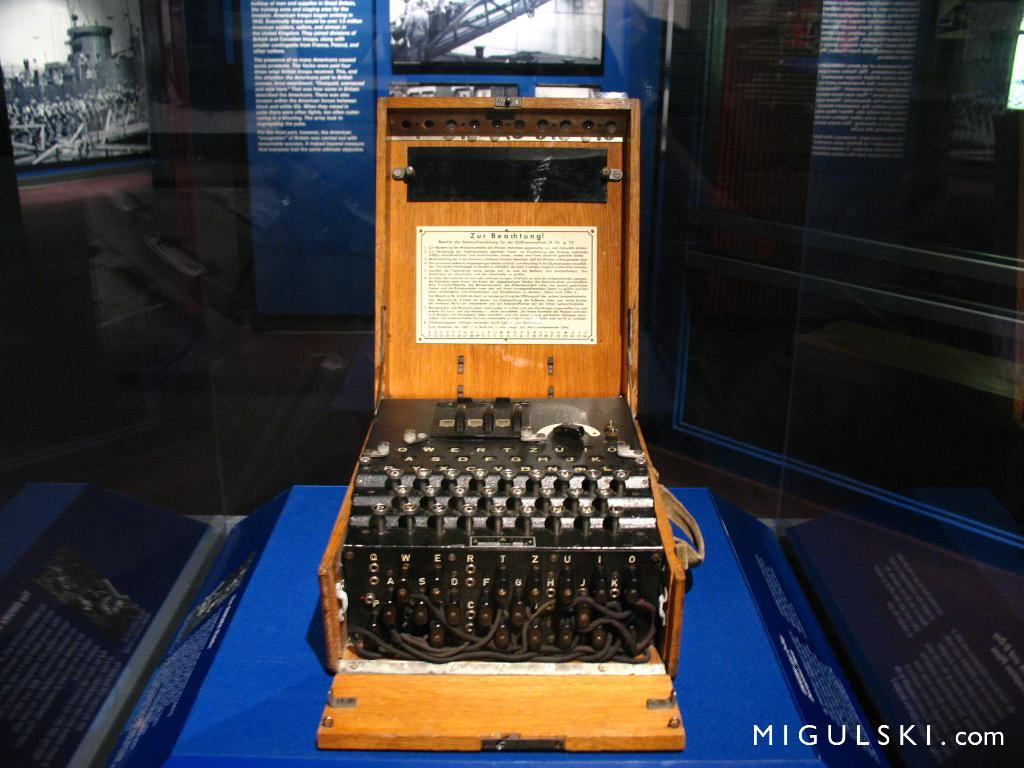What is located on the table in the image? There is a machine on the table in the image. What can be seen in the background of the image? There is a wall in the image. What type of visuals are present on the wall? There are posters with text in the image. What other types of images are visible in the image? There are photographs in the image. How many bubbles are floating around the machine in the image? There are no bubbles present in the image; it only features a machine, a wall, posters with text, and photographs. 